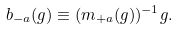<formula> <loc_0><loc_0><loc_500><loc_500>b _ { - a } ( g ) \equiv ( m _ { + a } ( g ) ) ^ { - 1 } g .</formula> 